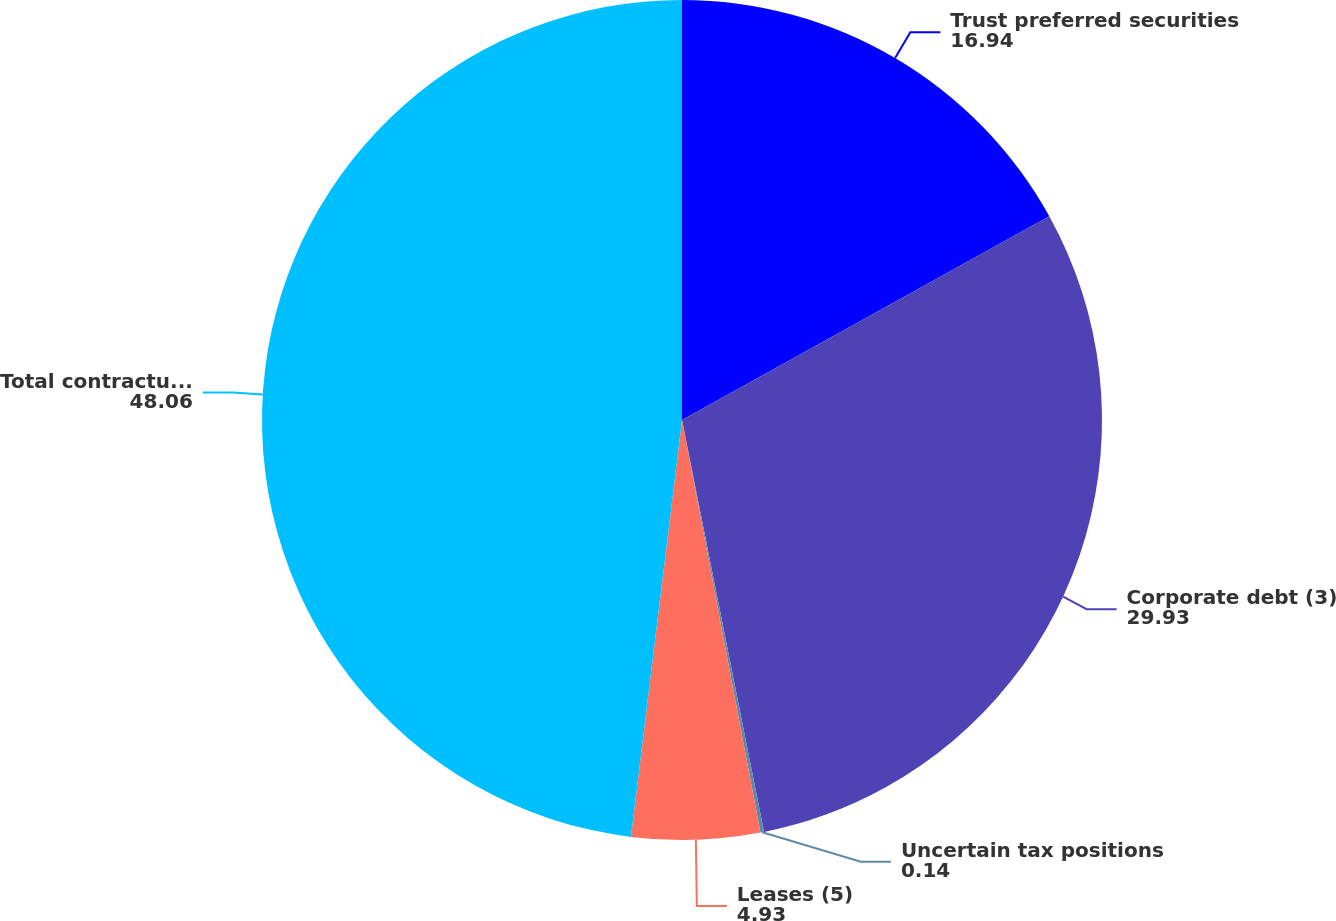Convert chart. <chart><loc_0><loc_0><loc_500><loc_500><pie_chart><fcel>Trust preferred securities<fcel>Corporate debt (3)<fcel>Uncertain tax positions<fcel>Leases (5)<fcel>Total contractual obligations<nl><fcel>16.94%<fcel>29.93%<fcel>0.14%<fcel>4.93%<fcel>48.06%<nl></chart> 